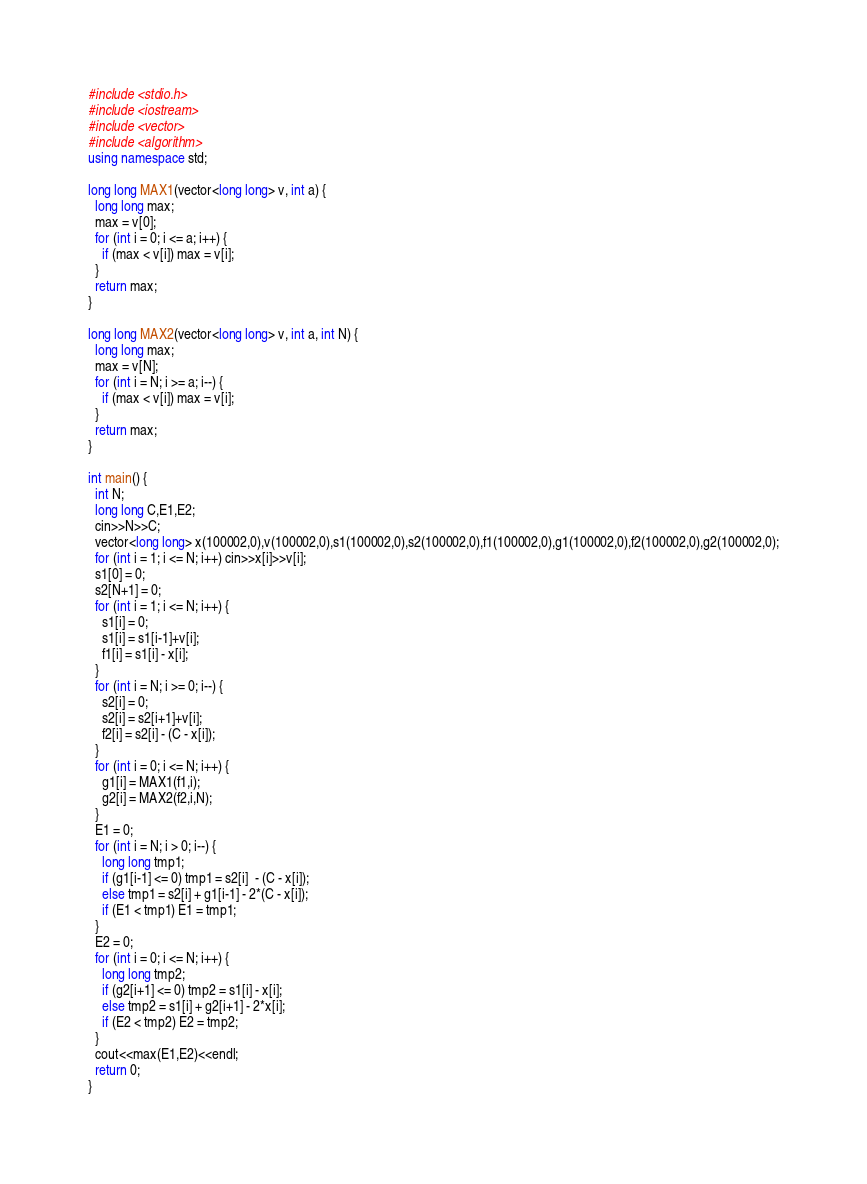<code> <loc_0><loc_0><loc_500><loc_500><_C++_>#include <stdio.h>
#include <iostream>
#include <vector>
#include <algorithm>
using namespace std;

long long MAX1(vector<long long> v, int a) {
  long long max;
  max = v[0];
  for (int i = 0; i <= a; i++) {
    if (max < v[i]) max = v[i];
  }
  return max;
}

long long MAX2(vector<long long> v, int a, int N) {
  long long max;
  max = v[N];
  for (int i = N; i >= a; i--) {
    if (max < v[i]) max = v[i];
  }
  return max;
}

int main() {
  int N;
  long long C,E1,E2;
  cin>>N>>C;
  vector<long long> x(100002,0),v(100002,0),s1(100002,0),s2(100002,0),f1(100002,0),g1(100002,0),f2(100002,0),g2(100002,0);
  for (int i = 1; i <= N; i++) cin>>x[i]>>v[i];
  s1[0] = 0;
  s2[N+1] = 0;
  for (int i = 1; i <= N; i++) {
    s1[i] = 0;
    s1[i] = s1[i-1]+v[i];
    f1[i] = s1[i] - x[i];
  }
  for (int i = N; i >= 0; i--) {
    s2[i] = 0;
    s2[i] = s2[i+1]+v[i];
    f2[i] = s2[i] - (C - x[i]);
  }
  for (int i = 0; i <= N; i++) {
    g1[i] = MAX1(f1,i);
    g2[i] = MAX2(f2,i,N);
  }
  E1 = 0;
  for (int i = N; i > 0; i--) {
    long long tmp1;
    if (g1[i-1] <= 0) tmp1 = s2[i]  - (C - x[i]);
    else tmp1 = s2[i] + g1[i-1] - 2*(C - x[i]);
    if (E1 < tmp1) E1 = tmp1;
  }
  E2 = 0;
  for (int i = 0; i <= N; i++) {
    long long tmp2;
    if (g2[i+1] <= 0) tmp2 = s1[i] - x[i];
    else tmp2 = s1[i] + g2[i+1] - 2*x[i];
    if (E2 < tmp2) E2 = tmp2;
  }
  cout<<max(E1,E2)<<endl;
  return 0;
}
</code> 